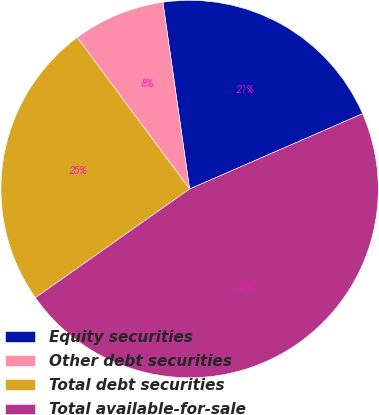Convert chart. <chart><loc_0><loc_0><loc_500><loc_500><pie_chart><fcel>Equity securities<fcel>Other debt securities<fcel>Total debt securities<fcel>Total available-for-sale<nl><fcel>20.72%<fcel>7.9%<fcel>24.61%<fcel>46.76%<nl></chart> 